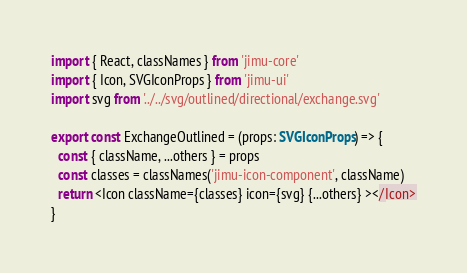Convert code to text. <code><loc_0><loc_0><loc_500><loc_500><_TypeScript_>import { React, classNames } from 'jimu-core'
import { Icon, SVGIconProps } from 'jimu-ui'
import svg from '../../svg/outlined/directional/exchange.svg'

export const ExchangeOutlined = (props: SVGIconProps) => {
  const { className, ...others } = props
  const classes = classNames('jimu-icon-component', className)
  return <Icon className={classes} icon={svg} {...others} ></Icon>
}
</code> 